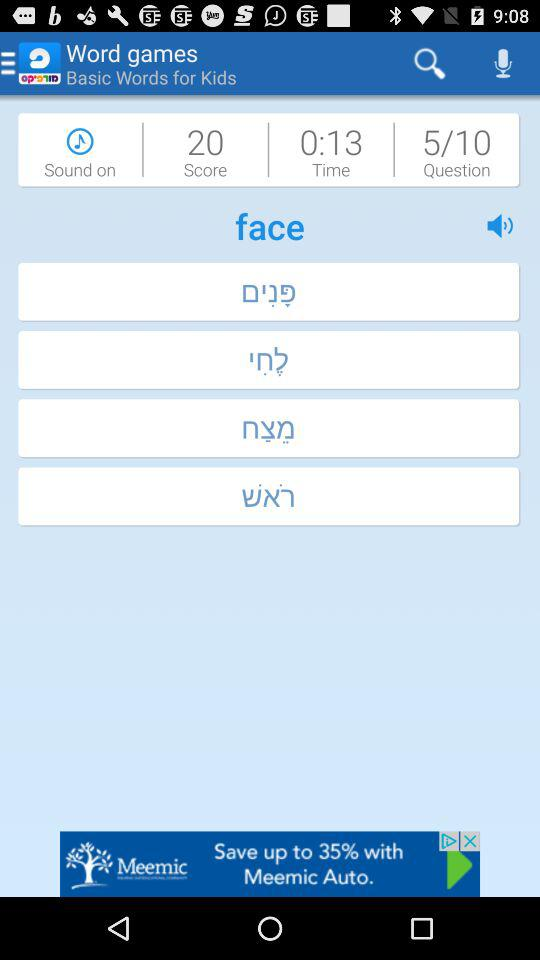What is the application name? The application name is "Morfix - English to Hebrew Translator & Dictionary". 